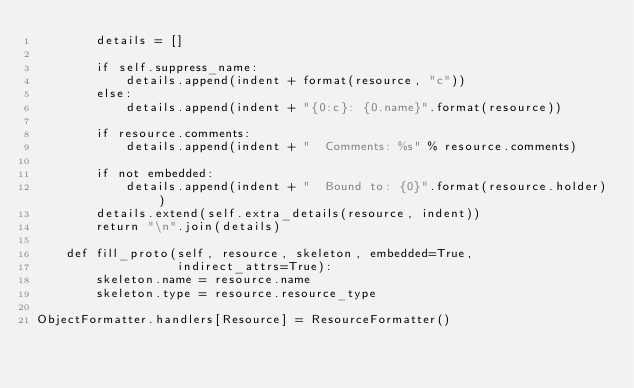Convert code to text. <code><loc_0><loc_0><loc_500><loc_500><_Python_>        details = []

        if self.suppress_name:
            details.append(indent + format(resource, "c"))
        else:
            details.append(indent + "{0:c}: {0.name}".format(resource))

        if resource.comments:
            details.append(indent + "  Comments: %s" % resource.comments)

        if not embedded:
            details.append(indent + "  Bound to: {0}".format(resource.holder))
        details.extend(self.extra_details(resource, indent))
        return "\n".join(details)

    def fill_proto(self, resource, skeleton, embedded=True,
                   indirect_attrs=True):
        skeleton.name = resource.name
        skeleton.type = resource.resource_type

ObjectFormatter.handlers[Resource] = ResourceFormatter()
</code> 